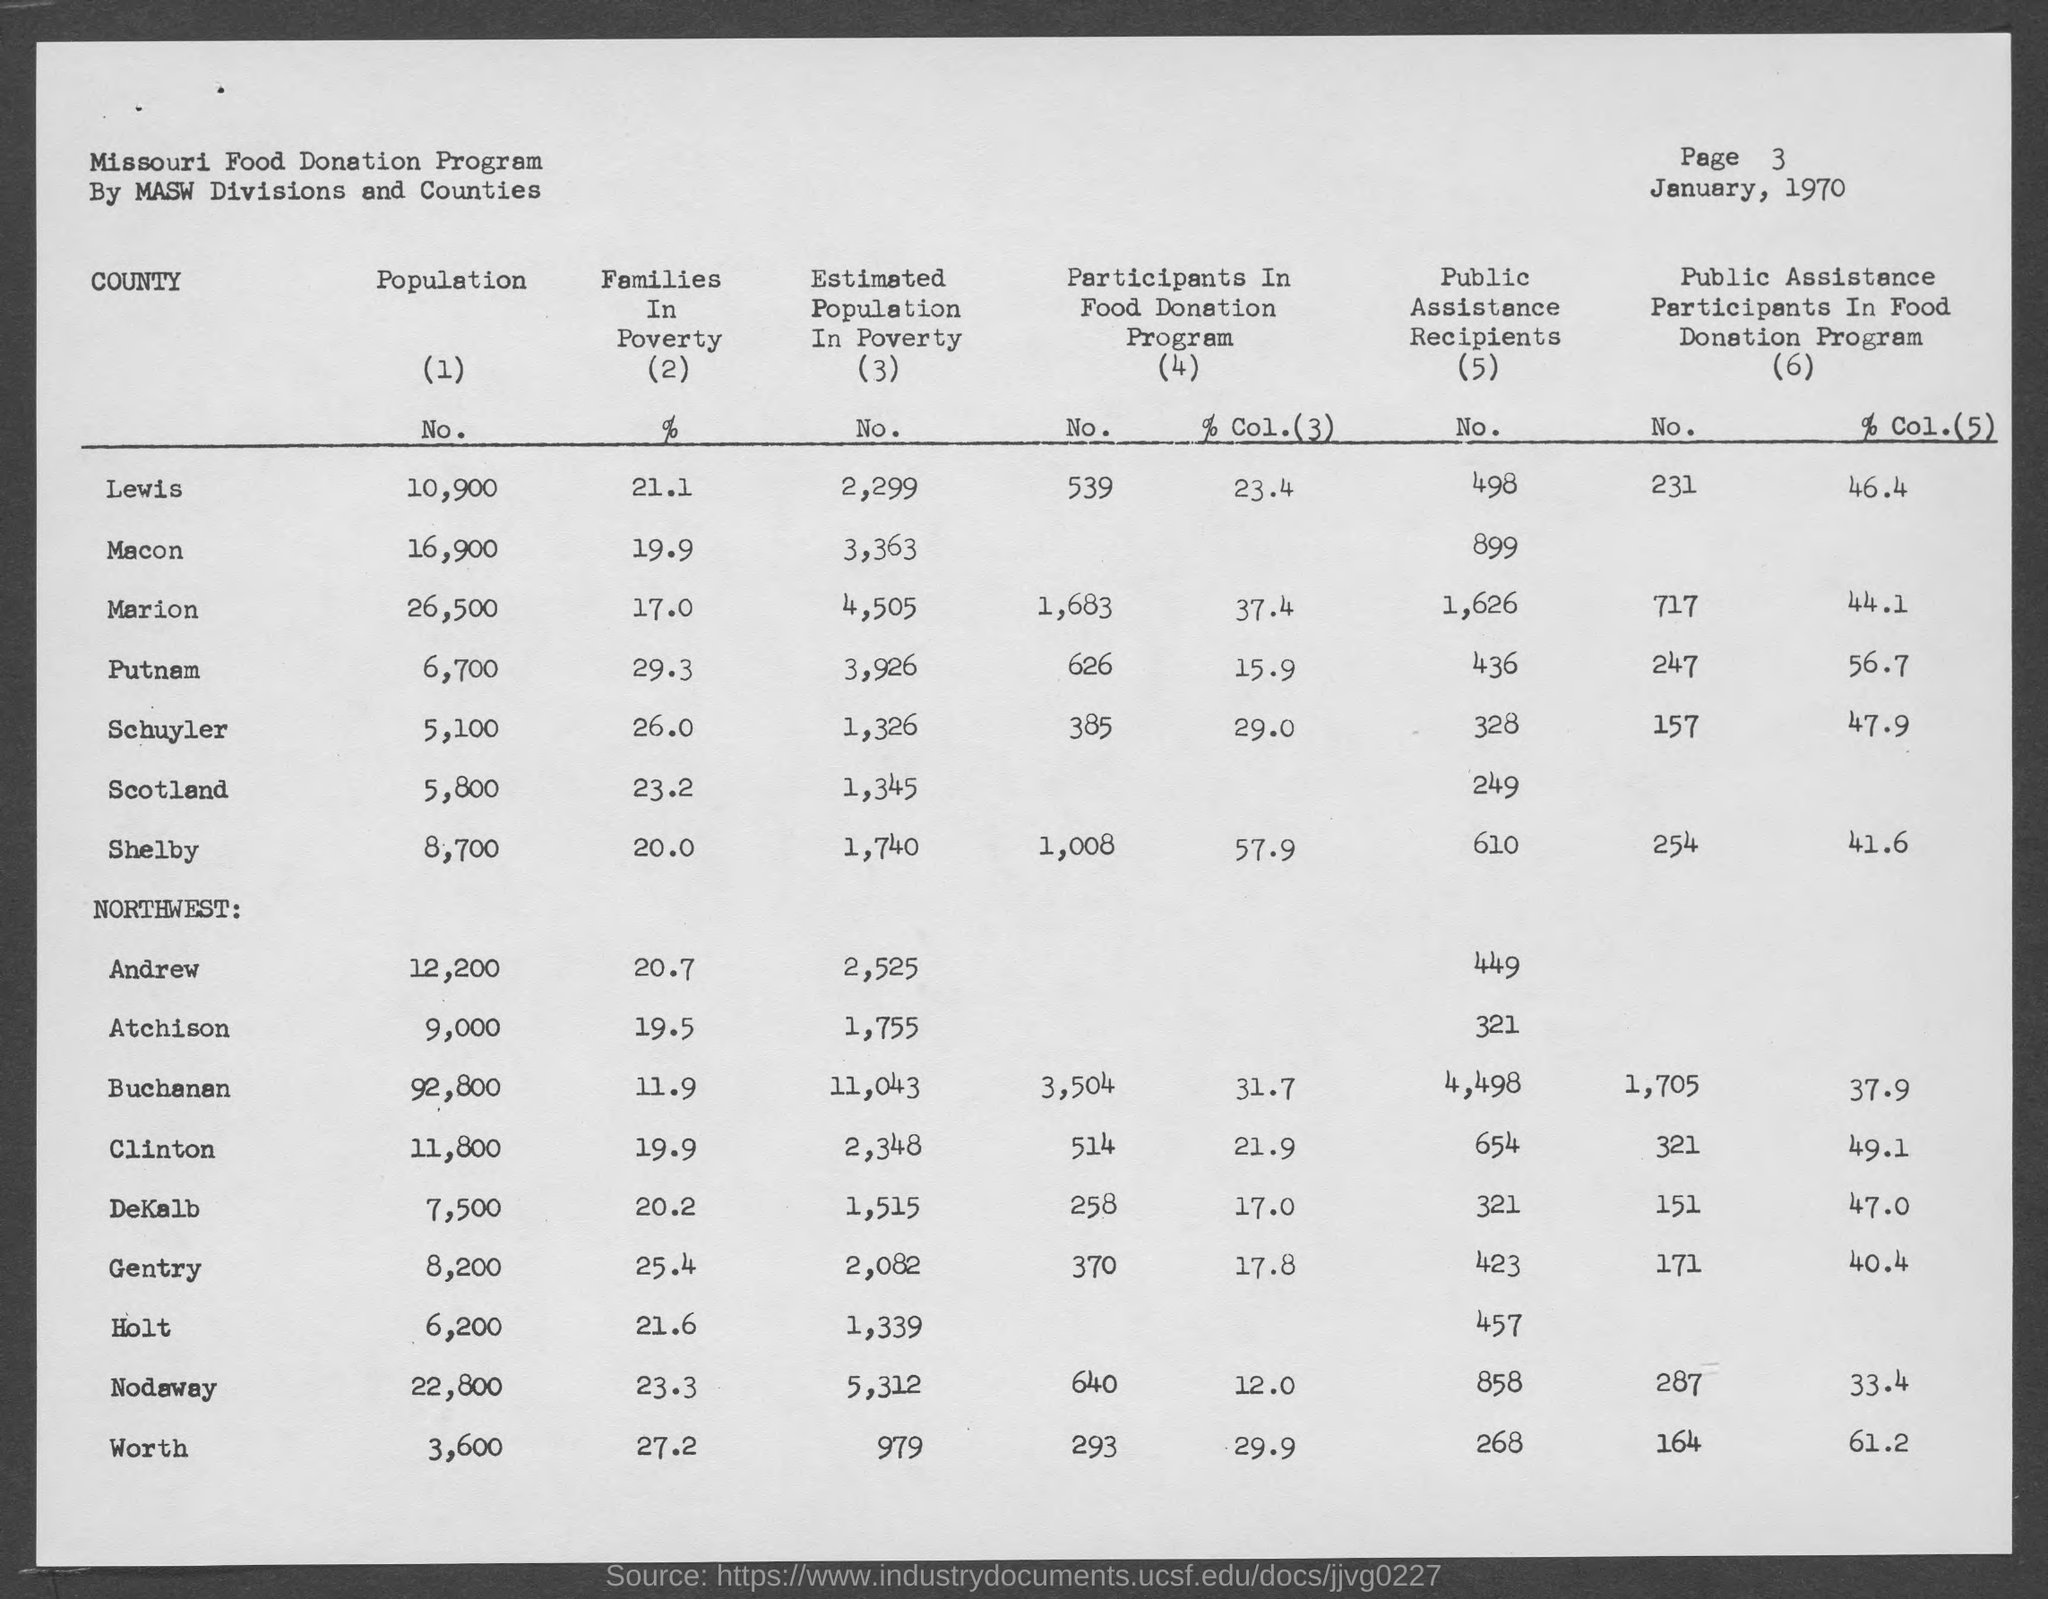What is the page number at top of the page?
Your answer should be compact. Page 3. What is the month and year at top of the page?
Your response must be concise. January, 1970. What is estimated population in poverty in lewis ?
Make the answer very short. 2,299. What is the estimated population in poverty in macon county ?
Offer a very short reply. 3,363. What is the estimated population in poverty in marion county?
Give a very brief answer. 4,505. What is the estimated population in poverty in putnam county ?
Your response must be concise. 3,926. What is the estimated population in poverty schuyler county ?
Ensure brevity in your answer.  1,326. What is the estimated population in poverty in scotland county ?
Provide a short and direct response. 1,345. What is the estimated population in poverty in shelby ?
Provide a succinct answer. 1,740. What is the estimated population in poverty in andrew county ?
Your response must be concise. 2,525. 